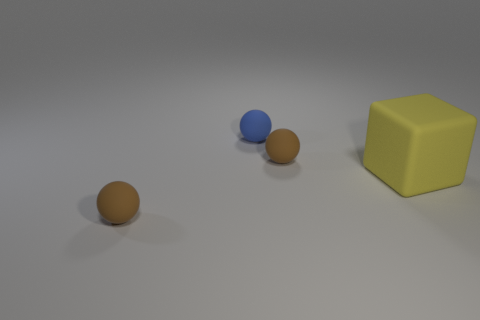Are there any other things that have the same shape as the yellow object?
Your answer should be very brief. No. How many metallic things are either small yellow objects or tiny brown things?
Ensure brevity in your answer.  0. Are there fewer blue things behind the small blue thing than tiny brown things?
Provide a short and direct response. Yes. What shape is the matte object to the right of the small brown sphere that is behind the tiny brown ball in front of the large object?
Provide a short and direct response. Cube. Is the number of large purple matte balls greater than the number of tiny spheres?
Your response must be concise. No. How many things are gray shiny blocks or objects that are to the left of the small blue ball?
Make the answer very short. 1. Is the number of large yellow objects less than the number of tiny matte things?
Offer a very short reply. Yes. What is the color of the big block behind the brown matte thing in front of the brown thing that is behind the large yellow thing?
Ensure brevity in your answer.  Yellow. There is a small blue thing; what number of yellow objects are behind it?
Your answer should be very brief. 0. How many blue things are cubes or spheres?
Keep it short and to the point. 1. 